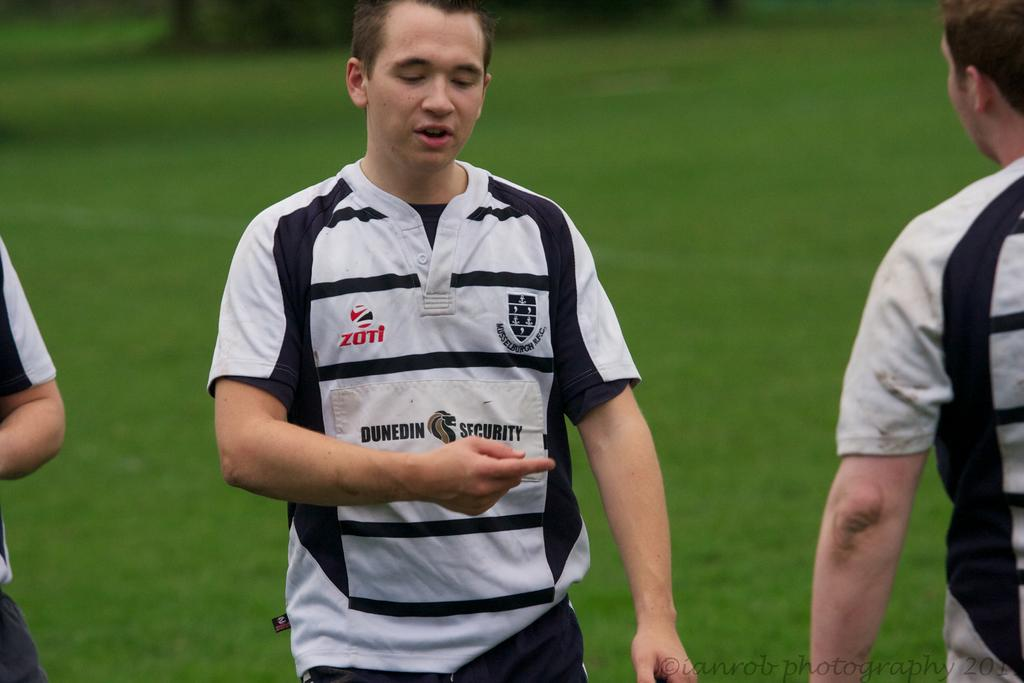<image>
Describe the image concisely. Two rugby team members talking to each other on the pitch, one wearing a shirt that says Dunedin Security. 